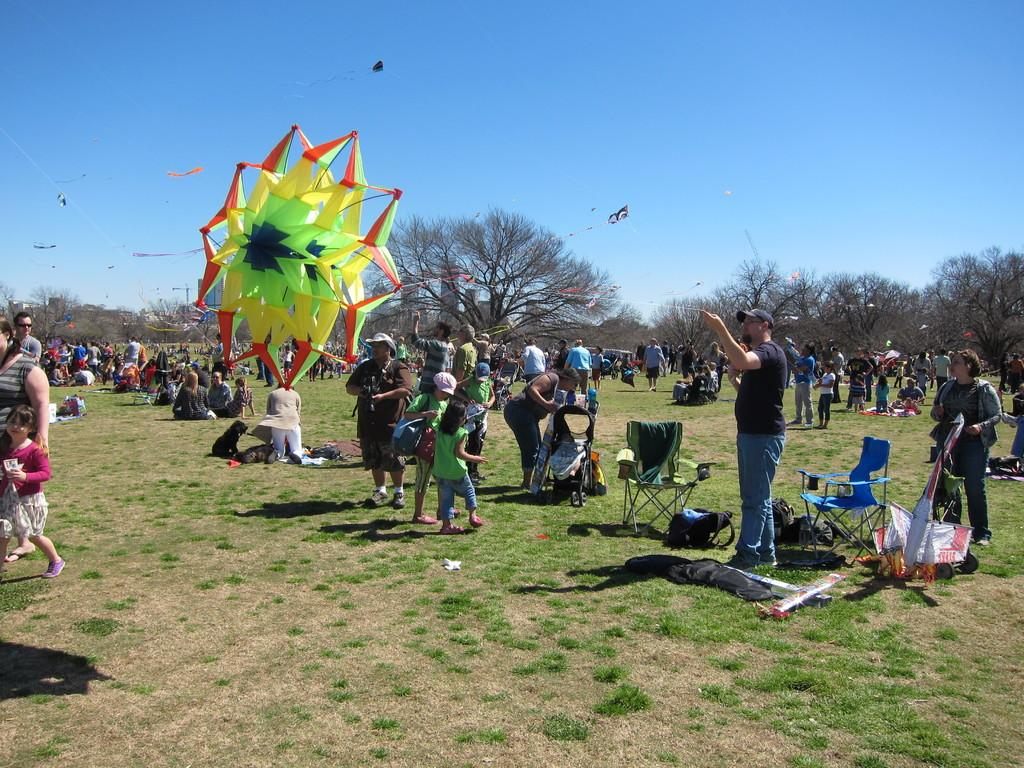What is the color of the sky in the image? The sky is blue in the image. What are the people doing in the image? There are kites in the image, which suggests that the people might be flying them. What type of furniture is present in the image? There are chairs in the image. What can be seen in the distance in the image? Trees are visible in the distance. What is the land covered with in the image? The land is covered with grass in the image. What type of seed is being planted by the people in the image? There is no indication in the image that people are planting seeds; they are flying kites instead. Can you tell me how many cannons are present in the image? There are no cannons present in the image. 